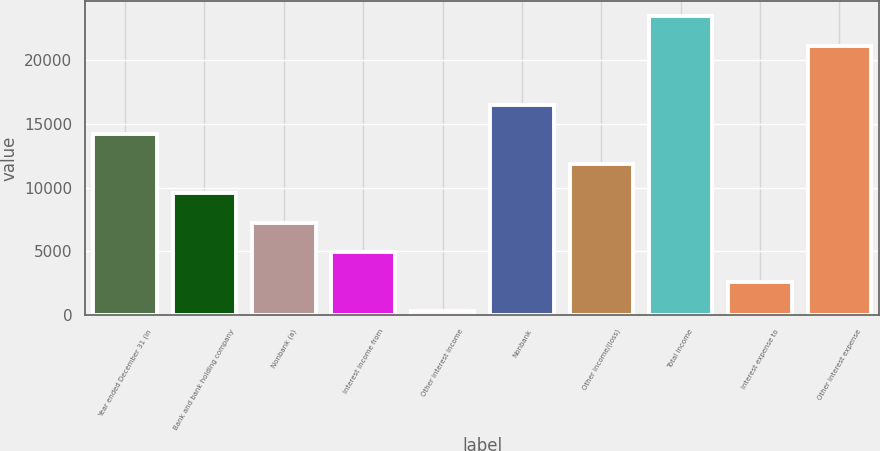Convert chart. <chart><loc_0><loc_0><loc_500><loc_500><bar_chart><fcel>Year ended December 31 (in<fcel>Bank and bank holding company<fcel>Nonbank (a)<fcel>Interest income from<fcel>Other interest income<fcel>Nonbank<fcel>Other income/(loss)<fcel>Total income<fcel>Interest expense to<fcel>Other interest expense<nl><fcel>14188.2<fcel>9559.8<fcel>7245.6<fcel>4931.4<fcel>303<fcel>16502.4<fcel>11874<fcel>23445<fcel>2617.2<fcel>21130.8<nl></chart> 